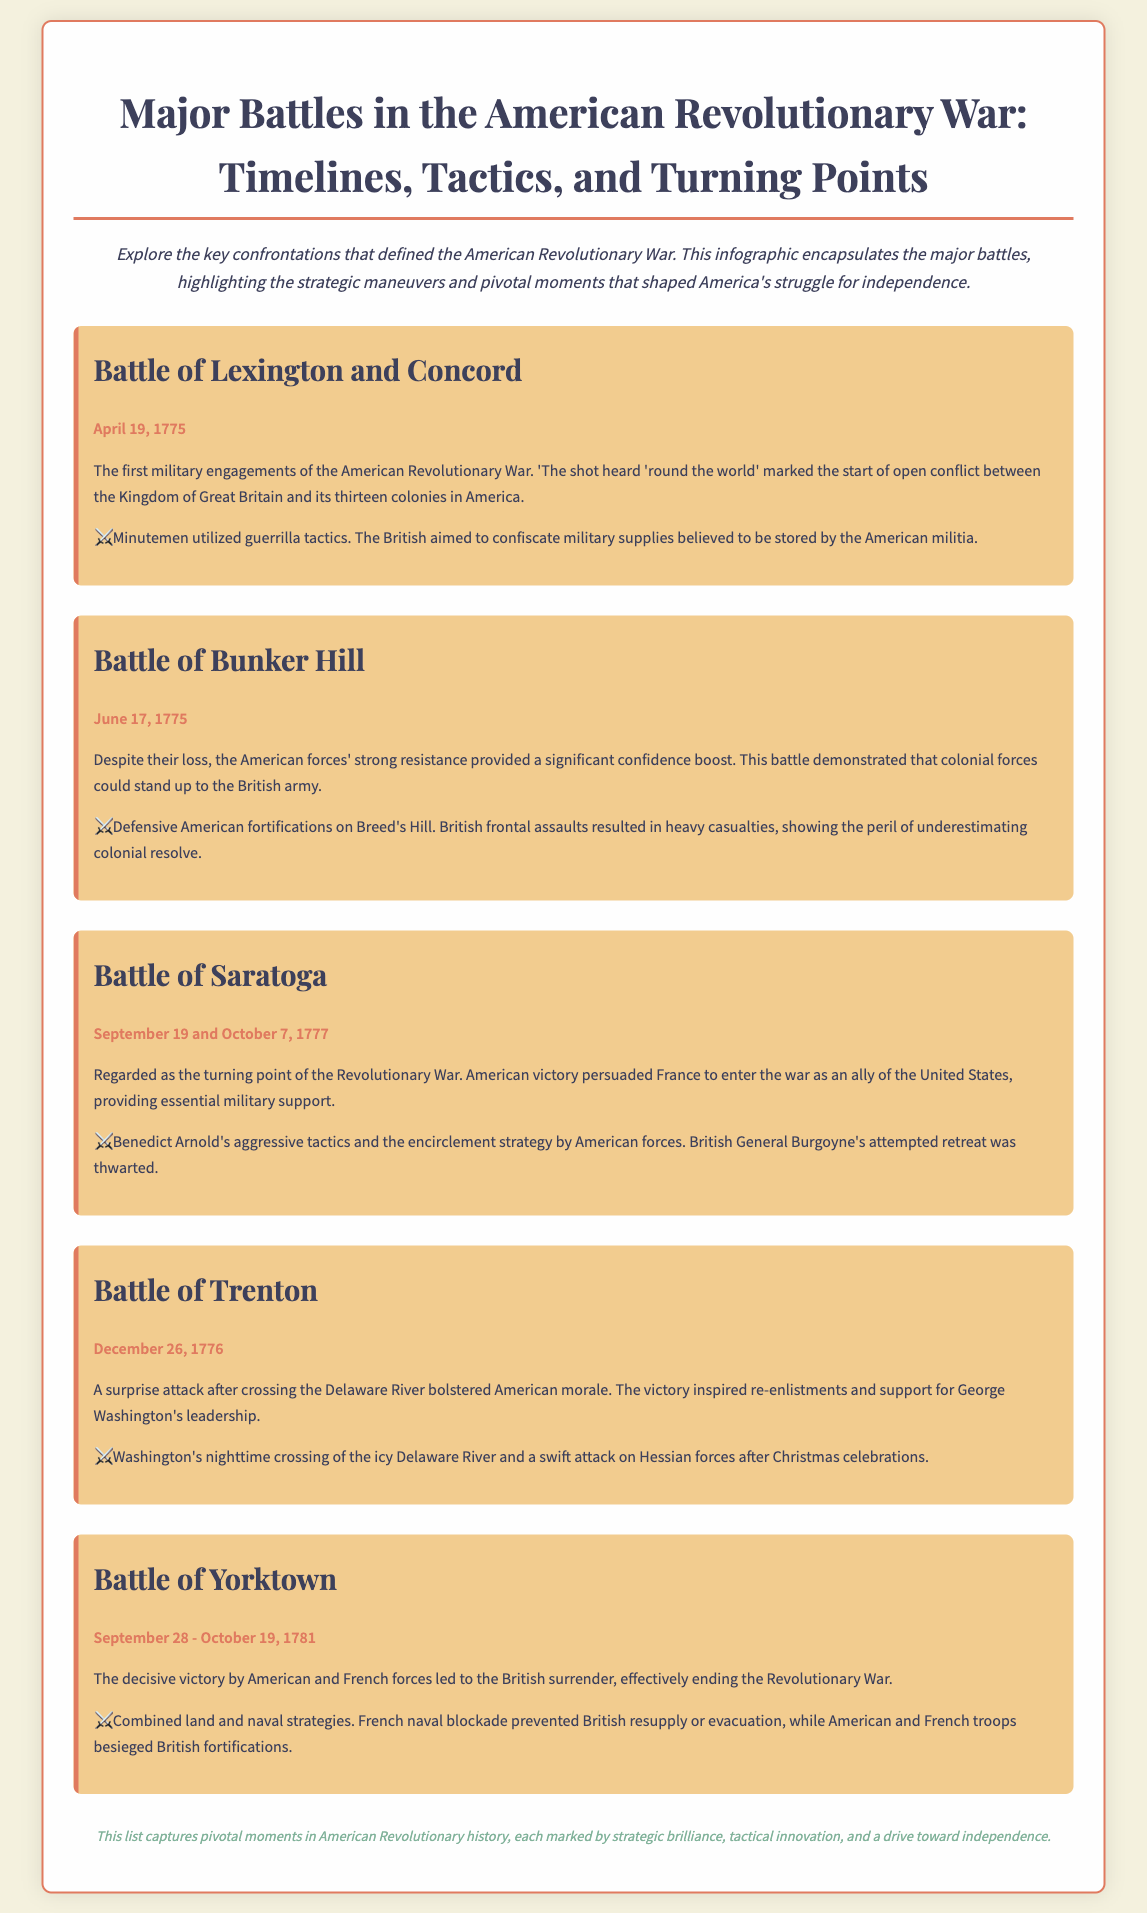What was the first battle of the American Revolutionary War? The document specifies that the first military engagements were the Battle of Lexington and Concord.
Answer: Battle of Lexington and Concord On what date did the Battle of Bunker Hill occur? The date of the Battle of Bunker Hill is explicitly mentioned as June 17, 1775.
Answer: June 17, 1775 Which battle is regarded as the turning point of the Revolutionary War? The document indicates that the Battle of Saratoga is viewed as the turning point of the war.
Answer: Battle of Saratoga What strategy did American forces use in the Battle of Trenton? The document notes Washington's nighttime crossing of the Delaware River followed by a swift attack on Hessian forces.
Answer: Nighttime crossing of the Delaware River What was the outcome of the Battle of Yorktown? The document states that the battle resulted in a decisive victory leading to British surrender.
Answer: Decisive victory leading to British surrender Which countries were involved at Yorktown? The document highlights the involvement of American and French forces in the battle.
Answer: American and French forces How did the Battle of Saratoga influence France? The document mentions that the American victory persuaded France to enter the war as an ally.
Answer: Persuaded France to enter the war What did the Battle of Bunker Hill demonstrate about colonial forces? The document explains that it showed colonial forces could stand up to the British army.
Answer: They could stand up to the British army What is the key tactic highlighted for the Battle of Lexington and Concord? The document notes that Minutemen utilized guerrilla tactics during the battle.
Answer: Guerrilla tactics 